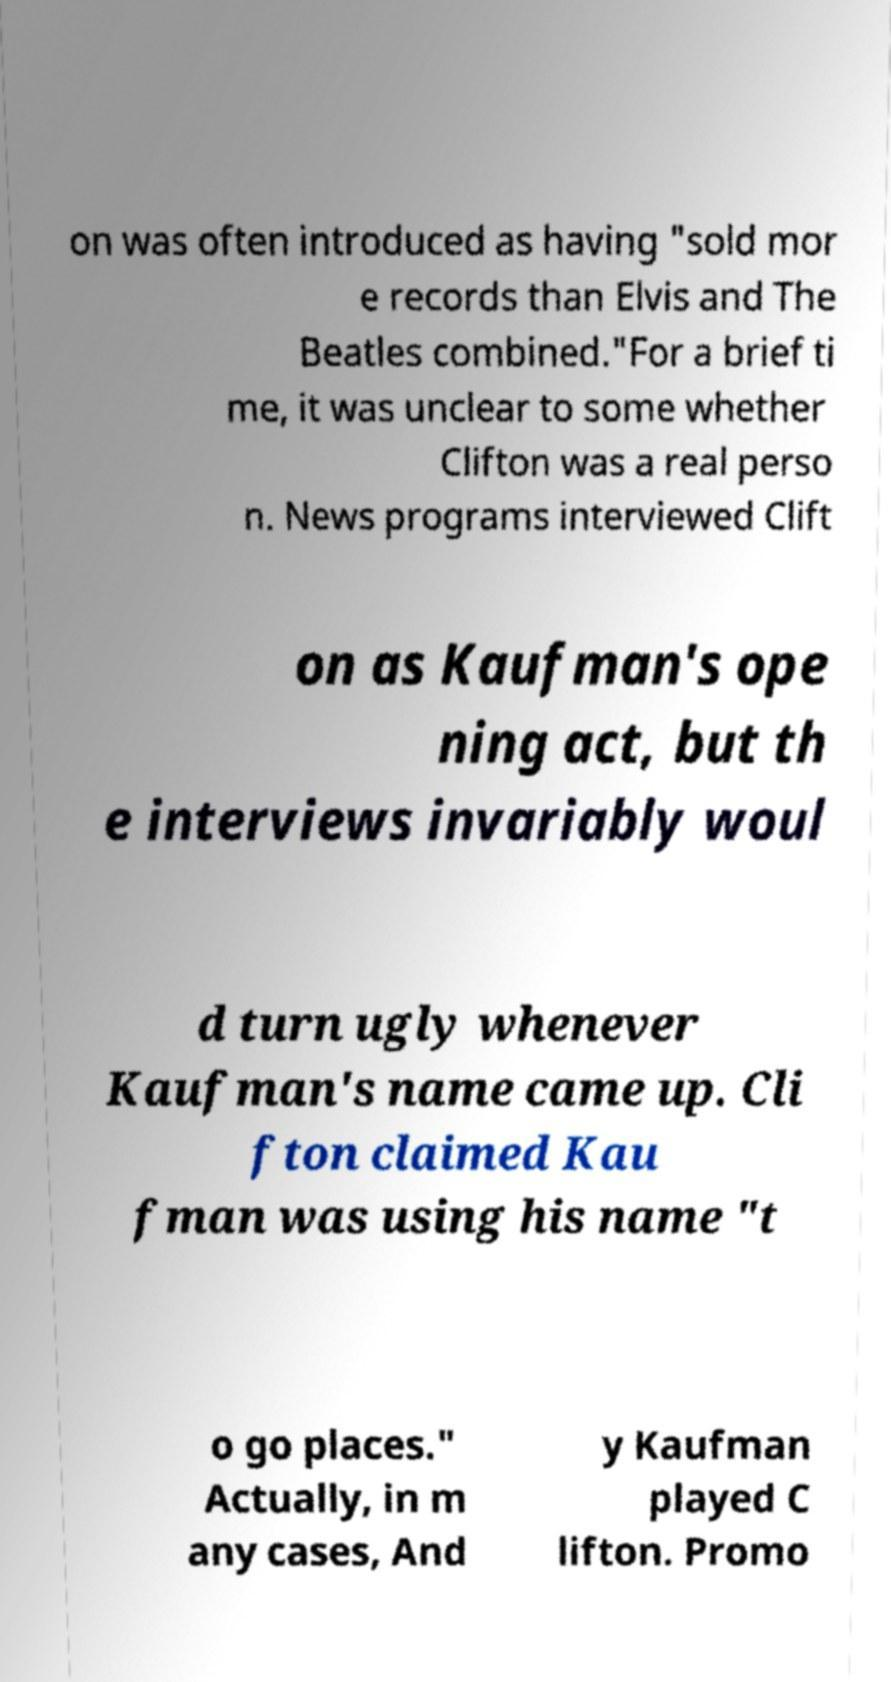Please identify and transcribe the text found in this image. on was often introduced as having "sold mor e records than Elvis and The Beatles combined."For a brief ti me, it was unclear to some whether Clifton was a real perso n. News programs interviewed Clift on as Kaufman's ope ning act, but th e interviews invariably woul d turn ugly whenever Kaufman's name came up. Cli fton claimed Kau fman was using his name "t o go places." Actually, in m any cases, And y Kaufman played C lifton. Promo 